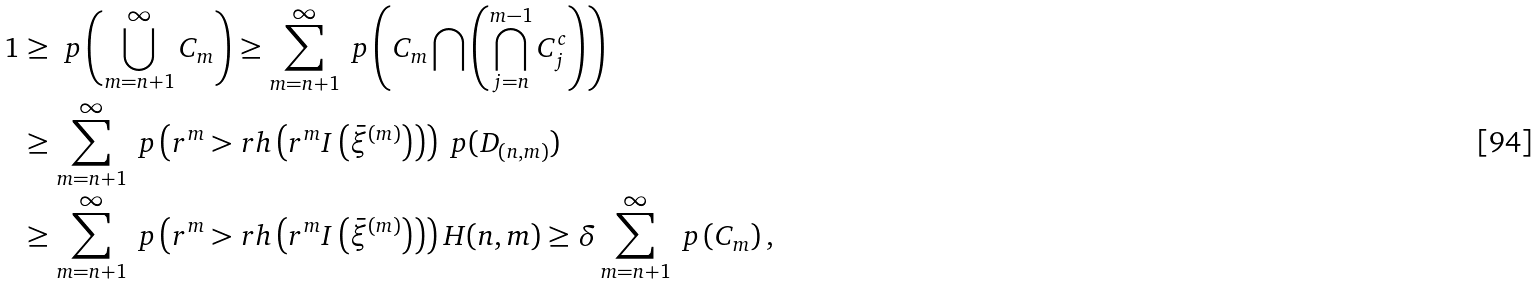<formula> <loc_0><loc_0><loc_500><loc_500>1 & \geq \ p \left ( \bigcup _ { m = n + 1 } ^ { \infty } C _ { m } \right ) \geq \sum _ { m = n + 1 } ^ { \infty } \ p \left ( C _ { m } \bigcap \left ( \bigcap _ { j = n } ^ { m - 1 } C ^ { c } _ { j } \right ) \right ) \\ & \geq \sum _ { m = n + 1 } ^ { \infty } \ p \left ( r ^ { m } > r h \left ( r ^ { m } I \left ( \bar { \xi } ^ { ( m ) } \right ) \right ) \right ) \ p ( D _ { ( n , m ) } ) \\ & \geq \sum _ { m = n + 1 } ^ { \infty } \ p \left ( r ^ { m } > r h \left ( r ^ { m } I \left ( \bar { \xi } ^ { ( m ) } \right ) \right ) \right ) H ( n , m ) \geq \delta \sum _ { m = n + 1 } ^ { \infty } \ p \left ( C _ { m } \right ) , \\</formula> 